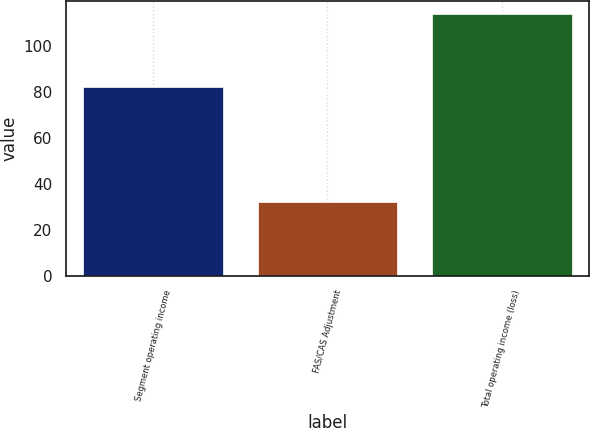Convert chart to OTSL. <chart><loc_0><loc_0><loc_500><loc_500><bar_chart><fcel>Segment operating income<fcel>FAS/CAS Adjustment<fcel>Total operating income (loss)<nl><fcel>82<fcel>32<fcel>114<nl></chart> 